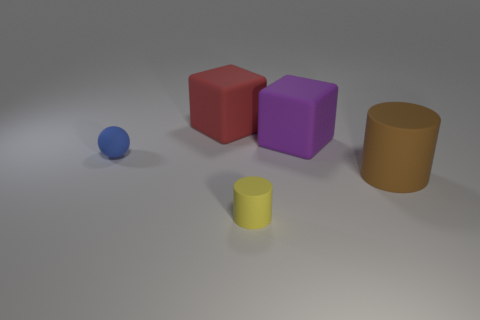How many other objects are there of the same color as the small cylinder?
Your answer should be compact. 0. How many small yellow cylinders are behind the small thing that is in front of the thing on the left side of the large red cube?
Your answer should be very brief. 0. Is the size of the matte block in front of the red block the same as the big matte cylinder?
Ensure brevity in your answer.  Yes. Are there fewer purple cubes that are in front of the blue thing than purple things that are behind the yellow matte cylinder?
Your response must be concise. Yes. Does the tiny sphere have the same color as the small rubber cylinder?
Make the answer very short. No. Are there fewer yellow objects right of the big purple matte thing than brown rubber spheres?
Provide a short and direct response. No. Is the material of the red cube the same as the tiny cylinder?
Keep it short and to the point. Yes. How many big cyan balls are the same material as the small blue thing?
Offer a terse response. 0. There is a large cylinder that is made of the same material as the red block; what is its color?
Offer a very short reply. Brown. The purple matte object has what shape?
Your answer should be very brief. Cube. 